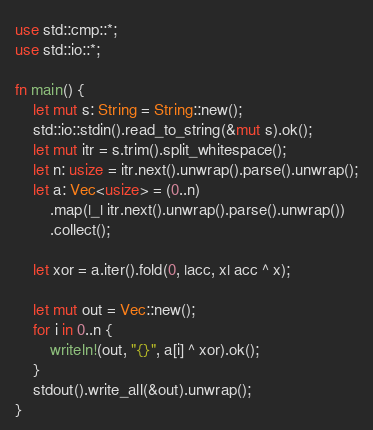Convert code to text. <code><loc_0><loc_0><loc_500><loc_500><_Rust_>use std::cmp::*;
use std::io::*;

fn main() {
    let mut s: String = String::new();
    std::io::stdin().read_to_string(&mut s).ok();
    let mut itr = s.trim().split_whitespace();
    let n: usize = itr.next().unwrap().parse().unwrap();
    let a: Vec<usize> = (0..n)
        .map(|_| itr.next().unwrap().parse().unwrap())
        .collect();

    let xor = a.iter().fold(0, |acc, x| acc ^ x);

    let mut out = Vec::new();
    for i in 0..n {
        writeln!(out, "{}", a[i] ^ xor).ok();
    }
    stdout().write_all(&out).unwrap();
}
</code> 